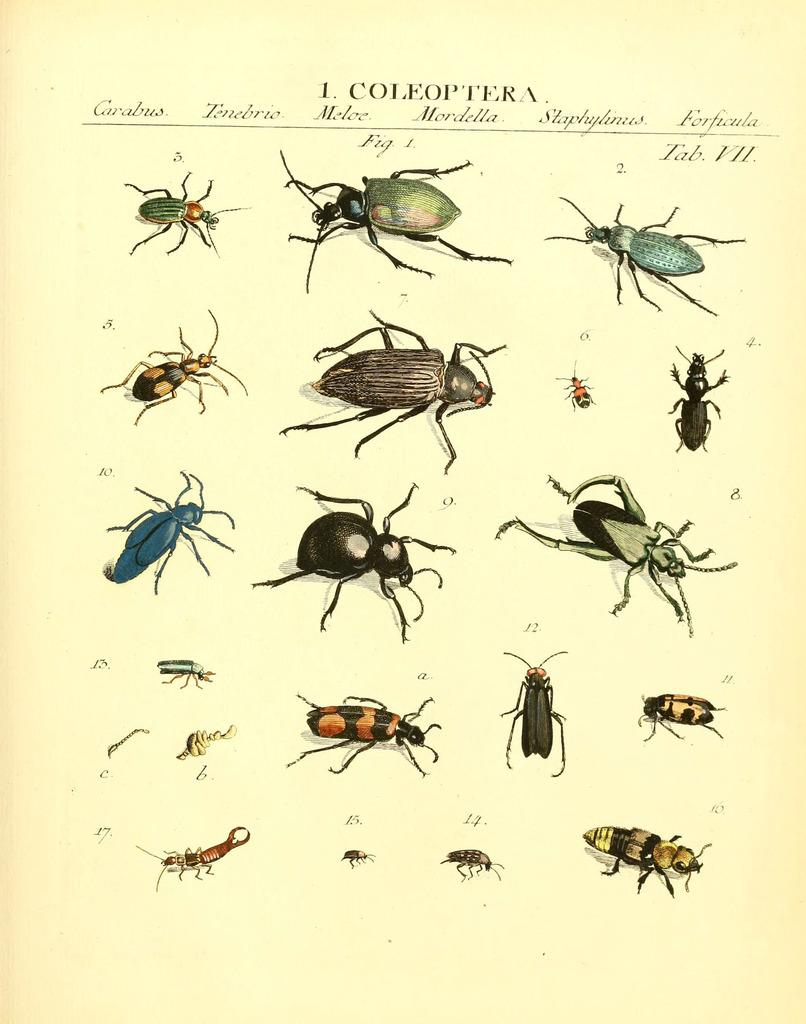What type of insects can be seen in the image? There are insects in the image, but the specific type cannot be determined without more information. What is written or depicted on the text in the image? Unfortunately, the content of the text cannot be determined without more information. Can you see a kitten playing with a pin near the insects in the image? No, there is no kitten or pin present in the image. 